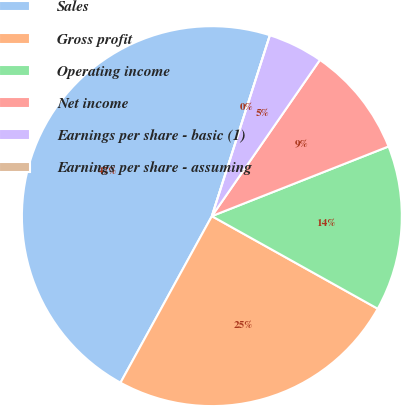Convert chart. <chart><loc_0><loc_0><loc_500><loc_500><pie_chart><fcel>Sales<fcel>Gross profit<fcel>Operating income<fcel>Net income<fcel>Earnings per share - basic (1)<fcel>Earnings per share - assuming<nl><fcel>46.95%<fcel>24.88%<fcel>14.08%<fcel>9.39%<fcel>4.69%<fcel>0.0%<nl></chart> 